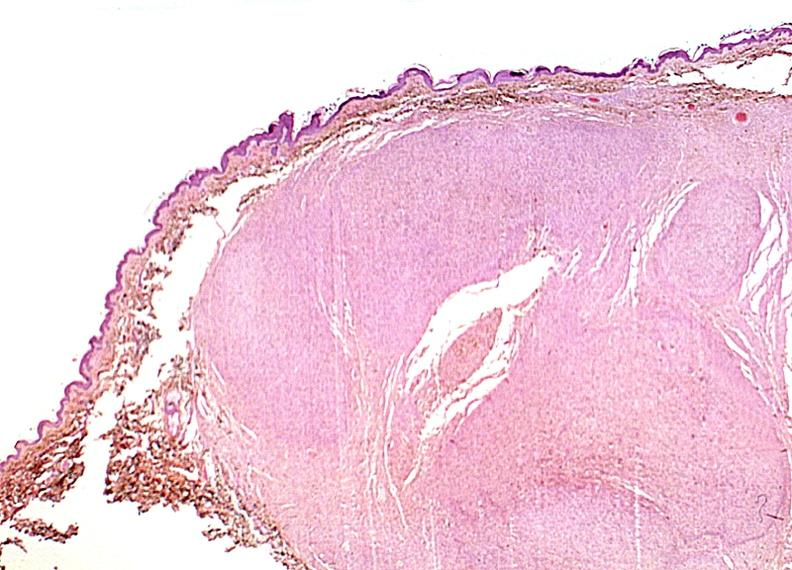does this image show skin, neurofibromatosis?
Answer the question using a single word or phrase. Yes 